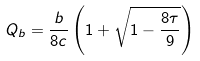<formula> <loc_0><loc_0><loc_500><loc_500>Q _ { b } = \frac { b } { 8 c } \left ( 1 + \sqrt { 1 - \frac { 8 \tau } { 9 } } \right )</formula> 